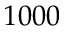Convert formula to latex. <formula><loc_0><loc_0><loc_500><loc_500>1 0 0 0</formula> 